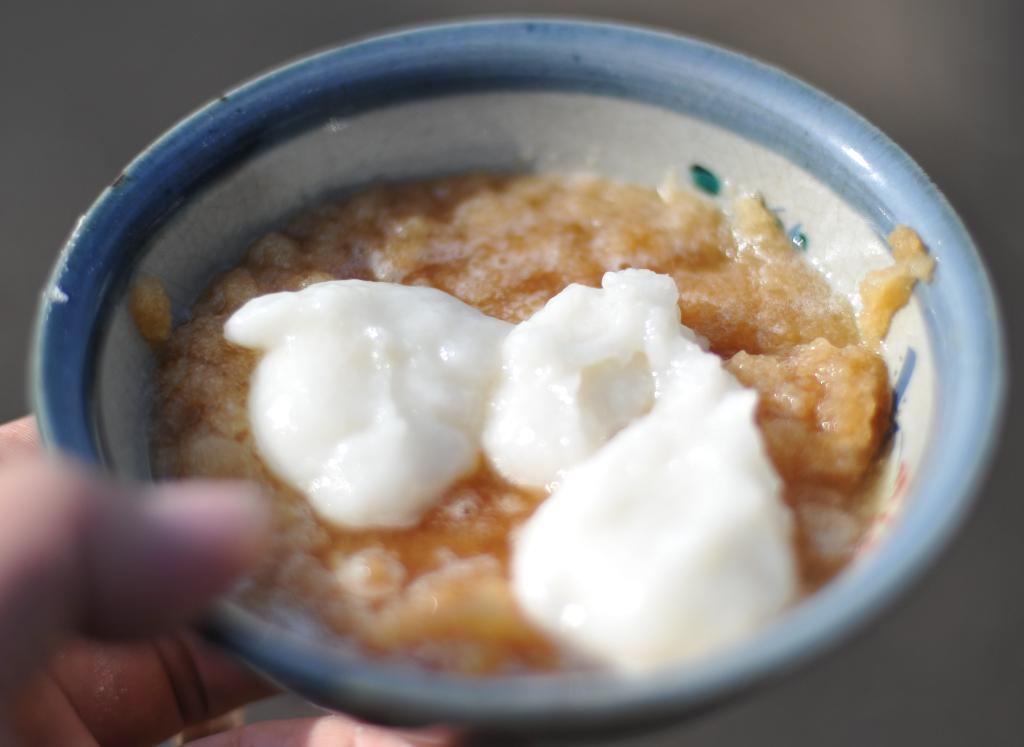Who is present in the image? There is a person in the image. What is the person holding in the image? The person is holding a bowl. What is in the bowl that the person is holding? There is food in the bowl. Can you describe the background of the image? The background of the image is blurry. What type of music can be heard coming from the bowl in the image? There is no music coming from the bowl in the image; it contains food. 